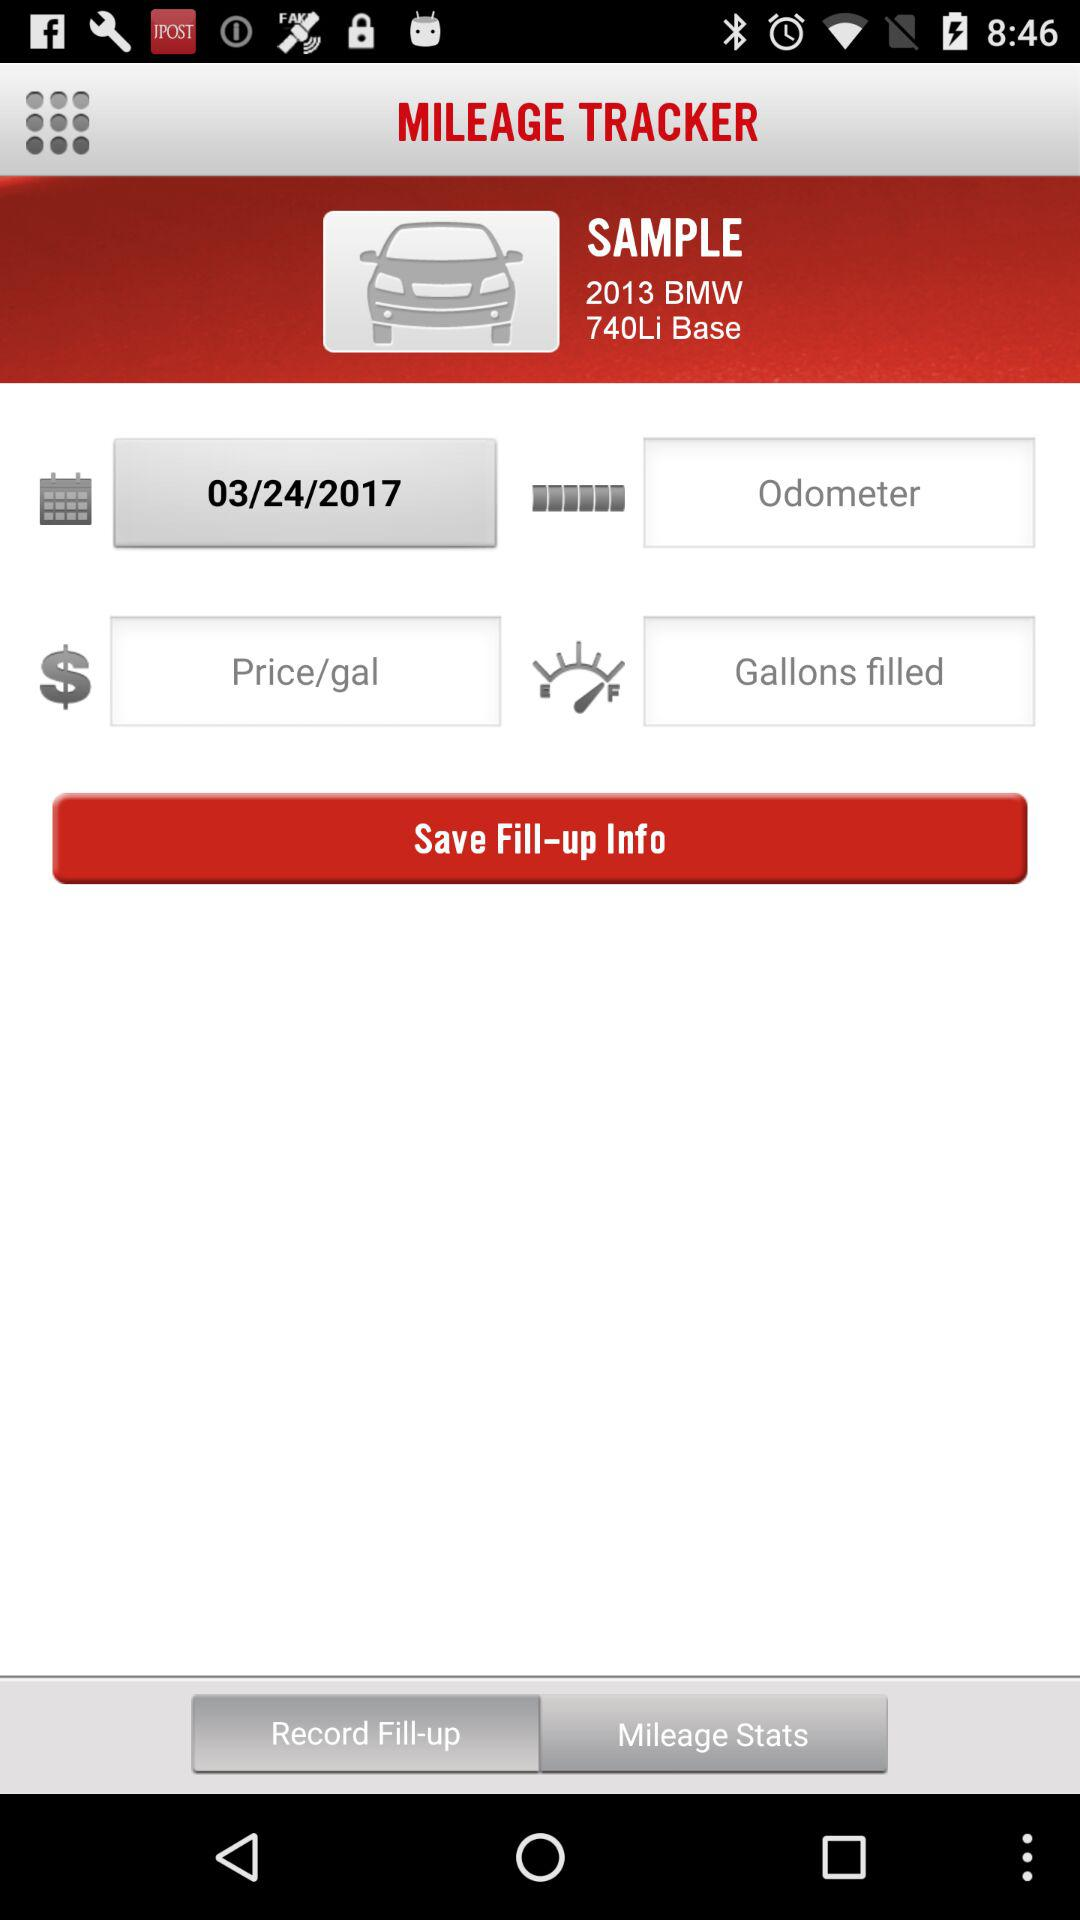What is the name of the application? The name of the application is "MILEAGE TRACKER". 